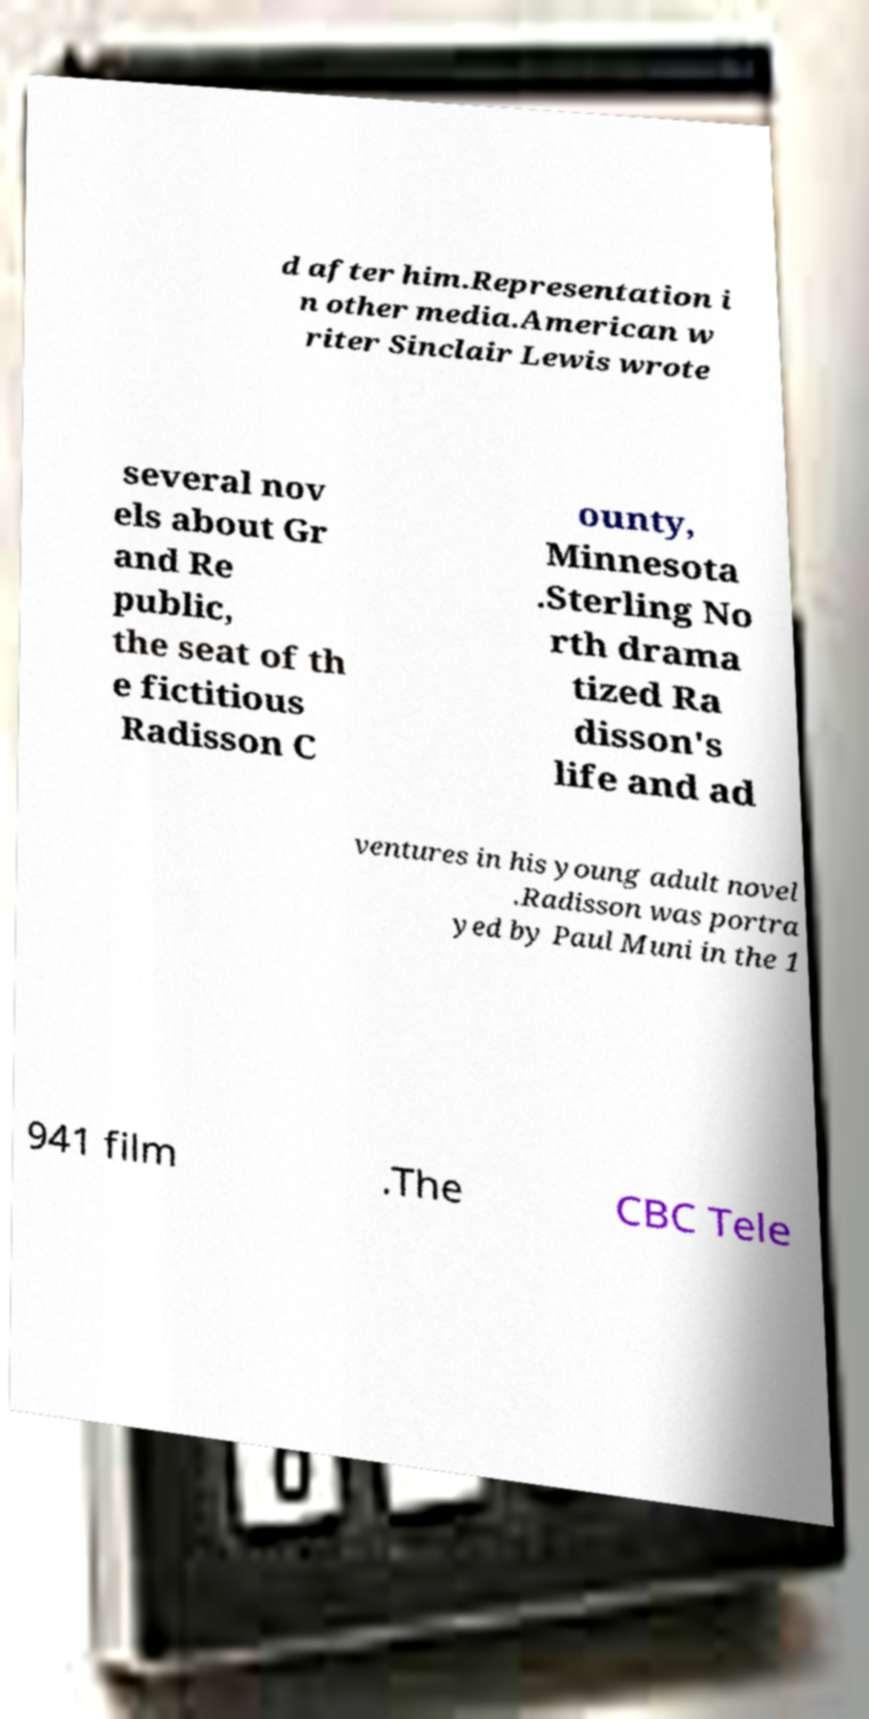Could you assist in decoding the text presented in this image and type it out clearly? d after him.Representation i n other media.American w riter Sinclair Lewis wrote several nov els about Gr and Re public, the seat of th e fictitious Radisson C ounty, Minnesota .Sterling No rth drama tized Ra disson's life and ad ventures in his young adult novel .Radisson was portra yed by Paul Muni in the 1 941 film .The CBC Tele 